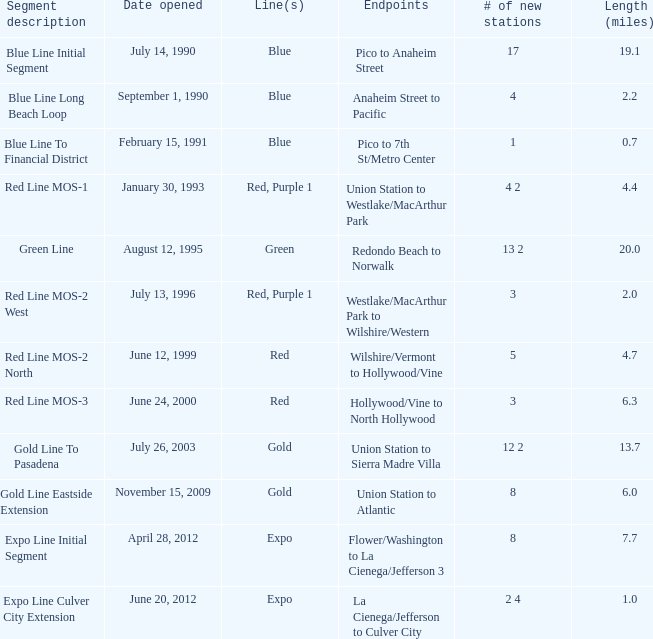How many new stations have a lenght (miles) of 6.0? 1.0. 